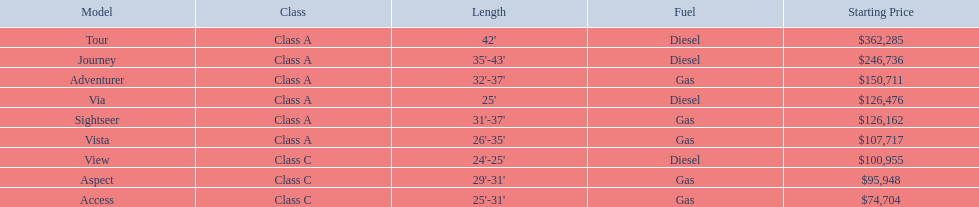Which models of winnebago are there? Tour, Journey, Adventurer, Via, Sightseer, Vista, View, Aspect, Access. Which ones are diesel? Tour, Journey, Sightseer, View. Which of those is the longest? Tour, Journey. Which one has the highest starting price? Tour. Which model has the lowest initial cost? Access. Which model has the second most elevated starting price? Journey. Which model has the highest pricing in the winnebago industry? Tour. What are the various winnebago models available? Tour, Journey, Adventurer, Via, Sightseer, Vista, View, Aspect, Access. Among them, which ones use diesel? Tour, Journey, Sightseer, View. Which model is the lengthiest? Tour, Journey. And which one has the highest initial cost? Tour. 